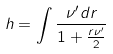Convert formula to latex. <formula><loc_0><loc_0><loc_500><loc_500>h = \int \frac { \nu ^ { \prime } d r } { 1 + \frac { r \nu ^ { \prime } } 2 }</formula> 